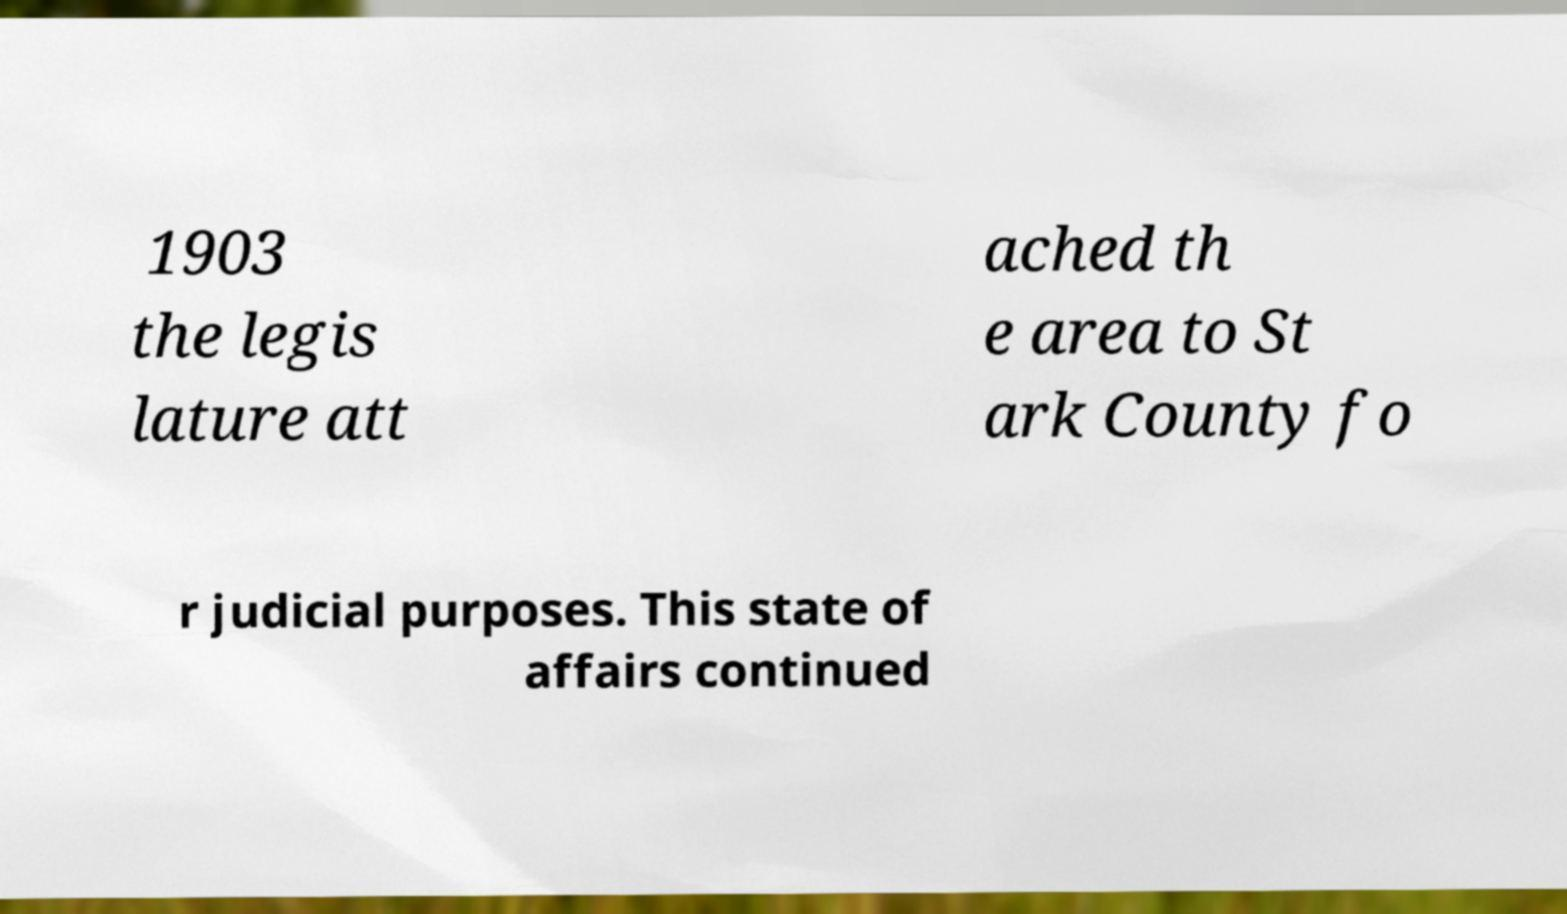Please read and relay the text visible in this image. What does it say? 1903 the legis lature att ached th e area to St ark County fo r judicial purposes. This state of affairs continued 